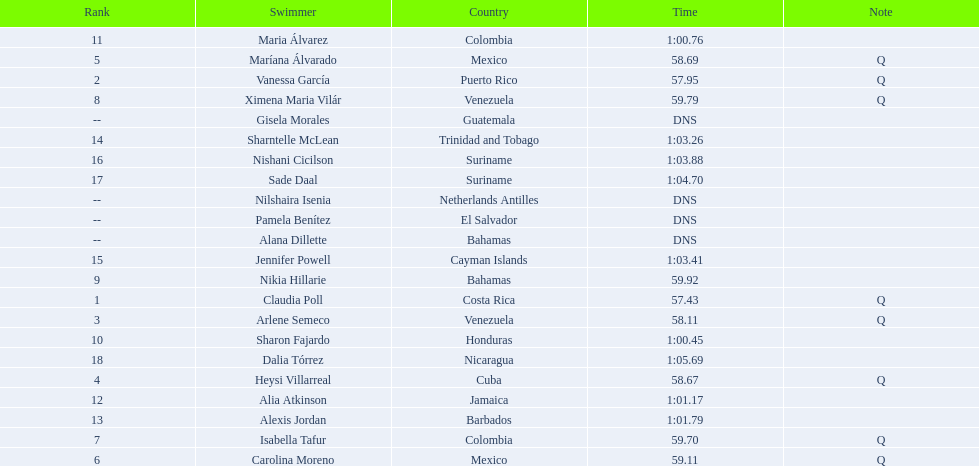What swimmer had the top or first rank? Claudia Poll. 